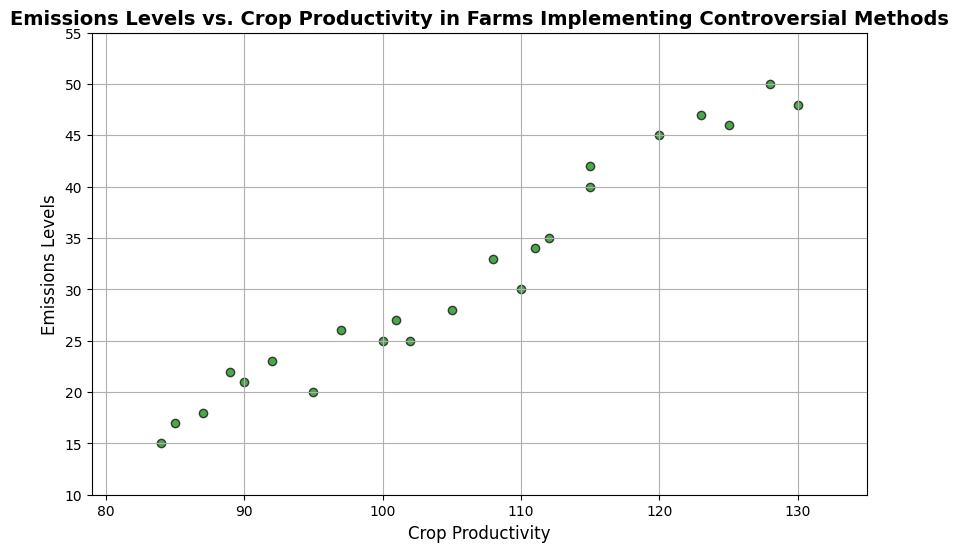What's the range of Crop Productivity values shown in the plot? The lowest Crop Productivity value is 84 and the highest is 130. To find the range, subtract the lowest value from the highest (130 - 84 = 46).
Answer: 46 Which data point has the highest emissions level, and what is the corresponding crop productivity? The highest emission level in the plot is 50, which corresponds to a Crop Productivity of 128.
Answer: 128 How many data points have crop productivity greater than 100? By counting the data points on the plot with crop productivity greater than 100, we see there are 12 such points.
Answer: 12 What is the average emission level of farms with crop productivity below 90? There are 3 data points with crop productivity below 90 (87, 84, 85) with emissions levels of 18, 15, and 17 respectively. Average emission level = (18 + 15 + 17) / 3 = 16.67.
Answer: 16.67 Is there a positive correlation between crop productivity and emissions levels? By visually inspecting the plot, we see that as Crop Productivity increases, Emissions Levels tend to increase as well, indicating a positive correlation.
Answer: Yes How many data points fall within the range of 90 to 110 for crop productivity? By counting the data points within the crop productivity range of 90 to 110, we find there are 7 such points.
Answer: 7 Which data point has the lowest emission level, and what is the corresponding crop productivity? The lowest emission level in the plot is 15, which corresponds to a Crop Productivity of 84.
Answer: 84 What is the difference in emission levels between the highest and lowest crop productivity values? The highest crop productivity value is 130 with an emission level of 48, and the lowest is 84 with an emission level of 15. Difference = 48 - 15 = 33.
Answer: 33 Which range of crop productivity (e.g., 80-100, 100-120, 120-140) has the highest number of data points? By dividing the crop productivity into ranges and counting data points, we find that the range 100-120 has 11 data points, the most among all.
Answer: 100-120 What can be inferred about farms with very high crop productivity (above 120) and their emission levels? Farms with very high crop productivity (above 120) seem to have higher emissions levels, as the data points for crop productivity greater than 120 are associated with emissions levels of 45, 47, 46, and 48.
Answer: High emissions levels 